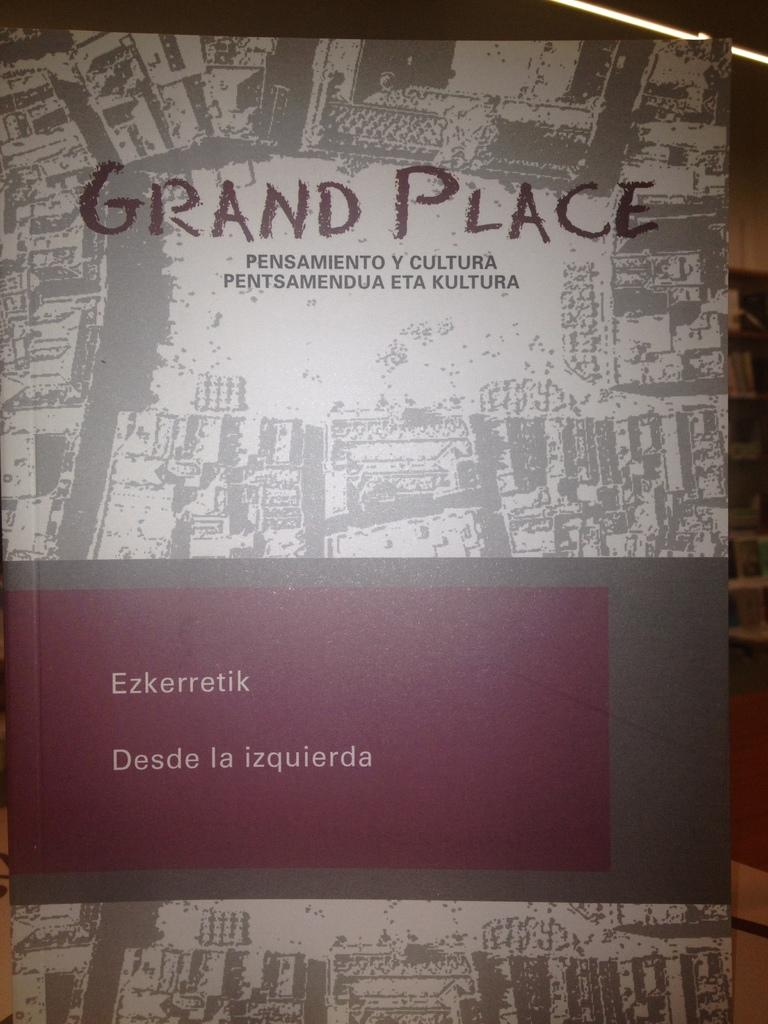<image>
Share a concise interpretation of the image provided. the words grand place that is on a book 